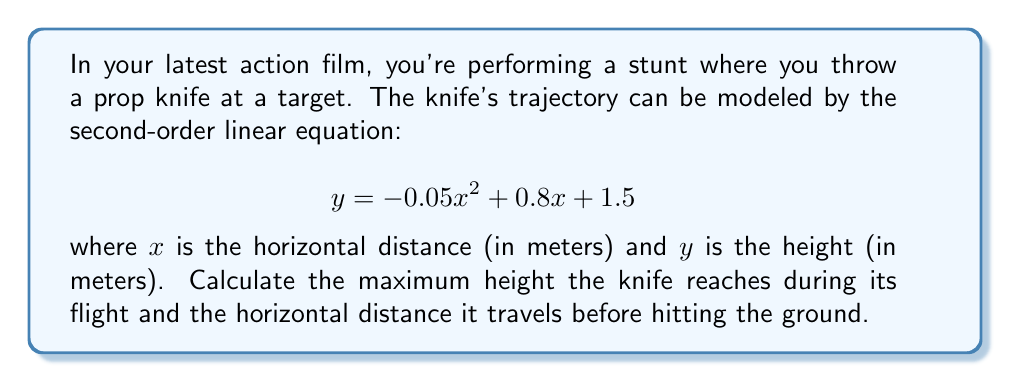Teach me how to tackle this problem. To solve this problem, we need to follow these steps:

1. Find the maximum height:
   The maximum height occurs at the vertex of the parabola. For a quadratic equation in the form $y = ax^2 + bx + c$, the x-coordinate of the vertex is given by $x = -\frac{b}{2a}$.

   Here, $a = -0.05$, $b = 0.8$, and $c = 1.5$

   $x = -\frac{0.8}{2(-0.05)} = 8$ meters

   To find the maximum height, we substitute this x-value back into the original equation:

   $y = -0.05(8)^2 + 0.8(8) + 1.5$
   $y = -0.05(64) + 6.4 + 1.5$
   $y = -3.2 + 6.4 + 1.5 = 4.7$ meters

2. Find the horizontal distance before hitting the ground:
   When the knife hits the ground, $y = 0$. We need to solve the equation:

   $0 = -0.05x^2 + 0.8x + 1.5$

   This is a quadratic equation. We can solve it using the quadratic formula:
   $x = \frac{-b \pm \sqrt{b^2 - 4ac}}{2a}$

   $x = \frac{-0.8 \pm \sqrt{0.8^2 - 4(-0.05)(1.5)}}{2(-0.05)}$

   $x = \frac{-0.8 \pm \sqrt{0.64 + 0.3}}{-0.1}$

   $x = \frac{-0.8 \pm \sqrt{0.94}}{-0.1}$

   $x = \frac{-0.8 \pm 0.9695}{-0.1}$

   This gives us two solutions:
   $x_1 = \frac{-0.8 + 0.9695}{-0.1} = -1.695$ meters
   $x_2 = \frac{-0.8 - 0.9695}{-0.1} = 17.695$ meters

   The negative solution doesn't make sense in this context, so we take the positive solution.
Answer: The knife reaches a maximum height of 4.7 meters and travels a horizontal distance of 17.695 meters before hitting the ground. 